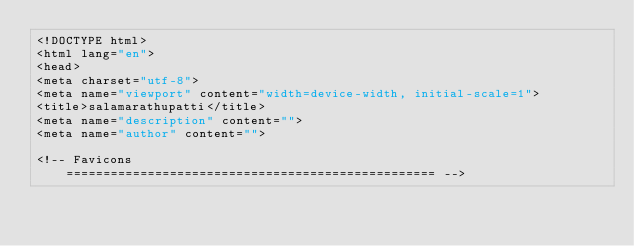<code> <loc_0><loc_0><loc_500><loc_500><_PHP_><!DOCTYPE html>
<html lang="en">
<head>
<meta charset="utf-8">
<meta name="viewport" content="width=device-width, initial-scale=1">
<title>salamarathupatti</title>
<meta name="description" content="">
<meta name="author" content="">

<!-- Favicons
    ================================================== --></code> 